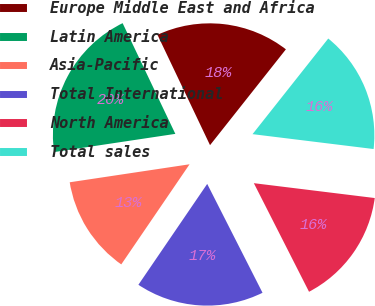Convert chart. <chart><loc_0><loc_0><loc_500><loc_500><pie_chart><fcel>Europe Middle East and Africa<fcel>Latin America<fcel>Asia-Pacific<fcel>Total International<fcel>North America<fcel>Total sales<nl><fcel>17.73%<fcel>20.3%<fcel>13.1%<fcel>17.01%<fcel>15.57%<fcel>16.29%<nl></chart> 